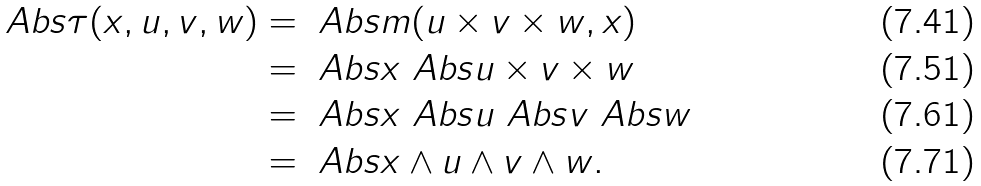<formula> <loc_0><loc_0><loc_500><loc_500>\ A b s { \tau ( x , u , v , w ) } & = \ A b s { m ( u \times v \times w , x ) } \\ & = \ A b s { x } \ A b s { u \times v \times w } \\ & = \ A b s { x } \ A b s { u } \ A b s { v } \ A b s { w } \\ & = \ A b s { x \wedge u \wedge v \wedge w } .</formula> 